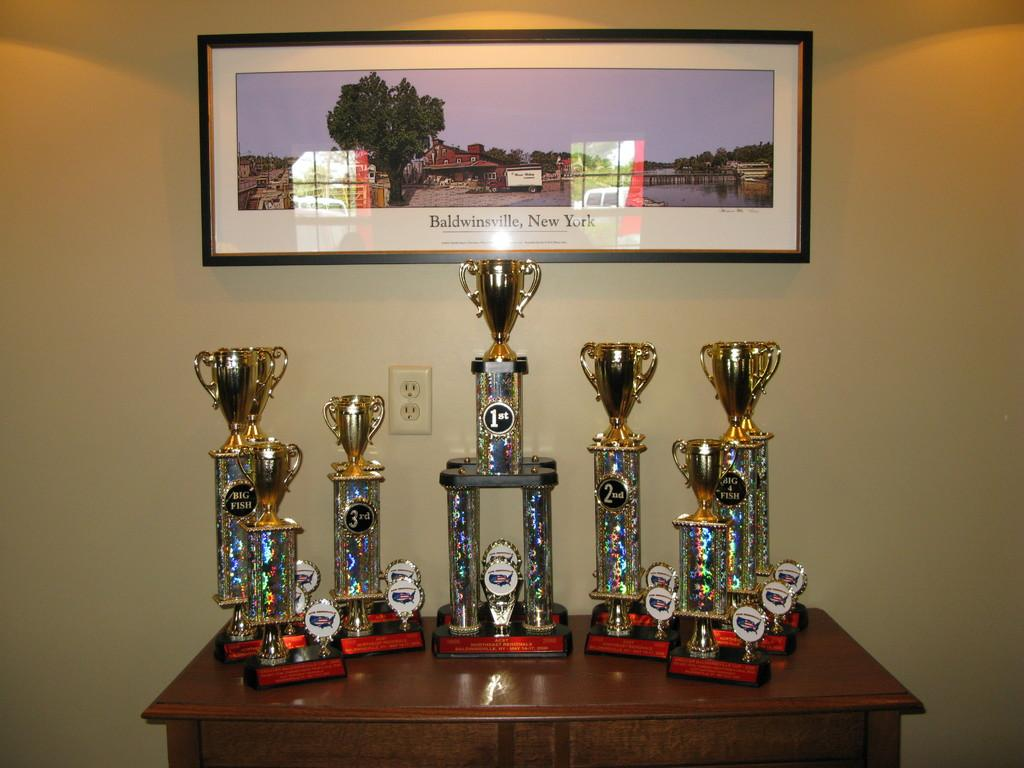<image>
Share a concise interpretation of the image provided. A picture of Baldwinsville New York above seven trophies. 